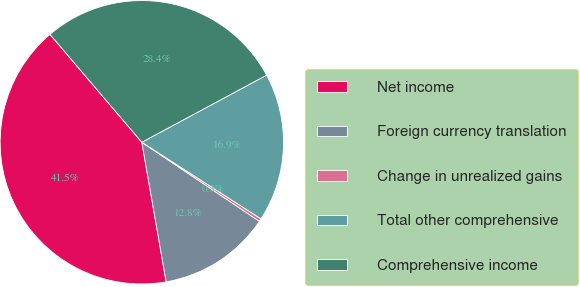Convert chart to OTSL. <chart><loc_0><loc_0><loc_500><loc_500><pie_chart><fcel>Net income<fcel>Foreign currency translation<fcel>Change in unrealized gains<fcel>Total other comprehensive<fcel>Comprehensive income<nl><fcel>41.53%<fcel>12.83%<fcel>0.33%<fcel>16.95%<fcel>28.37%<nl></chart> 